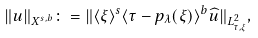Convert formula to latex. <formula><loc_0><loc_0><loc_500><loc_500>\| u \| _ { X ^ { s , b } } \colon = \| \langle \xi \rangle ^ { s } \langle \tau - p _ { \lambda } ( \xi ) \rangle ^ { b } \widehat { u } \| _ { L _ { \tau , \xi } ^ { 2 } } ,</formula> 